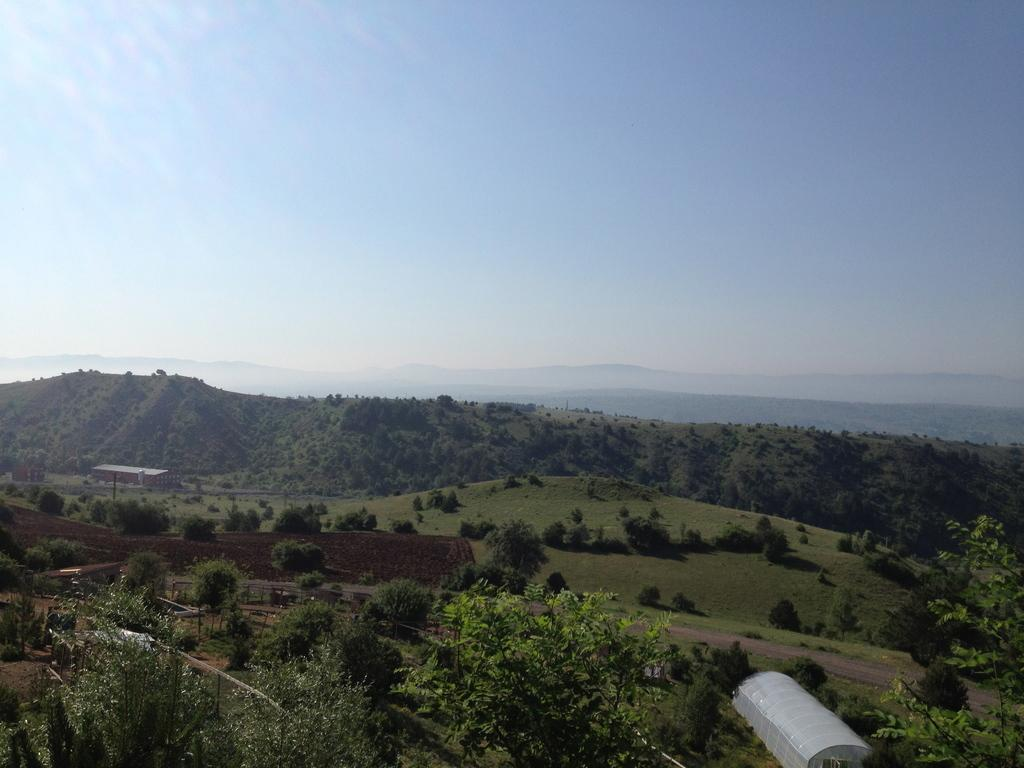What type of scene is shown in the image? The image depicts a scenery. What can be seen on the ground in the image? There are many trees on the ground. What is visible at the top of the image? The sky is visible at the top of the image. What type of structure can be seen on the right side of the image? There is a shed on the right side of the image. What type of learning material is being used by the band in the image? There is no band or learning material present in the image. 